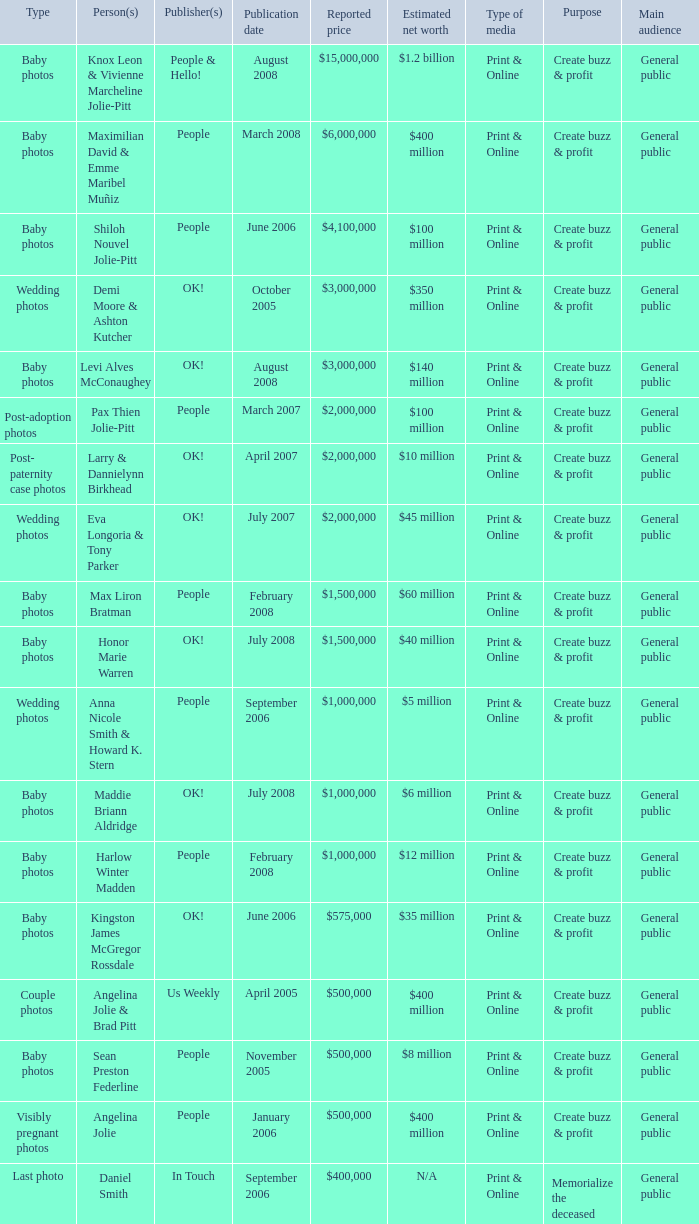What type of photos of Angelina Jolie cost $500,000? Visibly pregnant photos. 